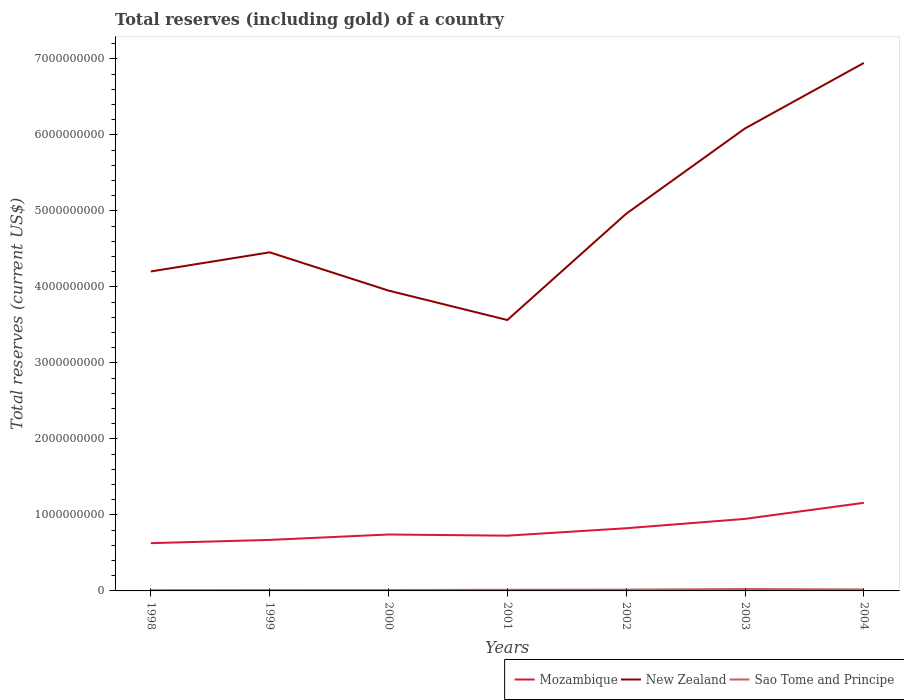How many different coloured lines are there?
Keep it short and to the point. 3. Does the line corresponding to Sao Tome and Principe intersect with the line corresponding to New Zealand?
Your answer should be compact. No. Is the number of lines equal to the number of legend labels?
Provide a succinct answer. Yes. Across all years, what is the maximum total reserves (including gold) in New Zealand?
Provide a succinct answer. 3.56e+09. What is the total total reserves (including gold) in New Zealand in the graph?
Make the answer very short. 6.39e+08. What is the difference between the highest and the second highest total reserves (including gold) in Mozambique?
Ensure brevity in your answer.  5.31e+08. What is the difference between the highest and the lowest total reserves (including gold) in Sao Tome and Principe?
Give a very brief answer. 3. How many lines are there?
Your answer should be very brief. 3. Are the values on the major ticks of Y-axis written in scientific E-notation?
Offer a terse response. No. Does the graph contain grids?
Make the answer very short. No. Where does the legend appear in the graph?
Ensure brevity in your answer.  Bottom right. What is the title of the graph?
Offer a very short reply. Total reserves (including gold) of a country. What is the label or title of the Y-axis?
Offer a very short reply. Total reserves (current US$). What is the Total reserves (current US$) of Mozambique in 1998?
Provide a short and direct response. 6.28e+08. What is the Total reserves (current US$) of New Zealand in 1998?
Make the answer very short. 4.20e+09. What is the Total reserves (current US$) in Sao Tome and Principe in 1998?
Provide a succinct answer. 9.68e+06. What is the Total reserves (current US$) of Mozambique in 1999?
Your answer should be compact. 6.71e+08. What is the Total reserves (current US$) in New Zealand in 1999?
Keep it short and to the point. 4.46e+09. What is the Total reserves (current US$) of Sao Tome and Principe in 1999?
Ensure brevity in your answer.  1.09e+07. What is the Total reserves (current US$) in Mozambique in 2000?
Your answer should be compact. 7.42e+08. What is the Total reserves (current US$) in New Zealand in 2000?
Your answer should be compact. 3.95e+09. What is the Total reserves (current US$) of Sao Tome and Principe in 2000?
Offer a very short reply. 1.16e+07. What is the Total reserves (current US$) of Mozambique in 2001?
Make the answer very short. 7.27e+08. What is the Total reserves (current US$) of New Zealand in 2001?
Provide a succinct answer. 3.56e+09. What is the Total reserves (current US$) in Sao Tome and Principe in 2001?
Your response must be concise. 1.55e+07. What is the Total reserves (current US$) of Mozambique in 2002?
Provide a succinct answer. 8.25e+08. What is the Total reserves (current US$) of New Zealand in 2002?
Your answer should be very brief. 4.96e+09. What is the Total reserves (current US$) in Sao Tome and Principe in 2002?
Make the answer very short. 1.74e+07. What is the Total reserves (current US$) in Mozambique in 2003?
Your response must be concise. 9.48e+08. What is the Total reserves (current US$) in New Zealand in 2003?
Your answer should be compact. 6.09e+09. What is the Total reserves (current US$) in Sao Tome and Principe in 2003?
Your response must be concise. 2.55e+07. What is the Total reserves (current US$) of Mozambique in 2004?
Offer a terse response. 1.16e+09. What is the Total reserves (current US$) of New Zealand in 2004?
Give a very brief answer. 6.95e+09. What is the Total reserves (current US$) in Sao Tome and Principe in 2004?
Provide a succinct answer. 1.95e+07. Across all years, what is the maximum Total reserves (current US$) in Mozambique?
Offer a terse response. 1.16e+09. Across all years, what is the maximum Total reserves (current US$) in New Zealand?
Keep it short and to the point. 6.95e+09. Across all years, what is the maximum Total reserves (current US$) in Sao Tome and Principe?
Make the answer very short. 2.55e+07. Across all years, what is the minimum Total reserves (current US$) in Mozambique?
Offer a terse response. 6.28e+08. Across all years, what is the minimum Total reserves (current US$) of New Zealand?
Provide a succinct answer. 3.56e+09. Across all years, what is the minimum Total reserves (current US$) in Sao Tome and Principe?
Your answer should be very brief. 9.68e+06. What is the total Total reserves (current US$) in Mozambique in the graph?
Your answer should be compact. 5.70e+09. What is the total Total reserves (current US$) of New Zealand in the graph?
Your response must be concise. 3.42e+1. What is the total Total reserves (current US$) in Sao Tome and Principe in the graph?
Your answer should be compact. 1.10e+08. What is the difference between the Total reserves (current US$) of Mozambique in 1998 and that in 1999?
Provide a succinct answer. -4.29e+07. What is the difference between the Total reserves (current US$) in New Zealand in 1998 and that in 1999?
Give a very brief answer. -2.52e+08. What is the difference between the Total reserves (current US$) of Sao Tome and Principe in 1998 and that in 1999?
Give a very brief answer. -1.19e+06. What is the difference between the Total reserves (current US$) of Mozambique in 1998 and that in 2000?
Offer a terse response. -1.14e+08. What is the difference between the Total reserves (current US$) of New Zealand in 1998 and that in 2000?
Make the answer very short. 2.52e+08. What is the difference between the Total reserves (current US$) in Sao Tome and Principe in 1998 and that in 2000?
Offer a terse response. -1.96e+06. What is the difference between the Total reserves (current US$) of Mozambique in 1998 and that in 2001?
Your answer should be very brief. -9.85e+07. What is the difference between the Total reserves (current US$) in New Zealand in 1998 and that in 2001?
Your answer should be compact. 6.39e+08. What is the difference between the Total reserves (current US$) of Sao Tome and Principe in 1998 and that in 2001?
Your answer should be compact. -5.80e+06. What is the difference between the Total reserves (current US$) of Mozambique in 1998 and that in 2002?
Make the answer very short. -1.96e+08. What is the difference between the Total reserves (current US$) in New Zealand in 1998 and that in 2002?
Provide a succinct answer. -7.59e+08. What is the difference between the Total reserves (current US$) of Sao Tome and Principe in 1998 and that in 2002?
Offer a very short reply. -7.67e+06. What is the difference between the Total reserves (current US$) in Mozambique in 1998 and that in 2003?
Offer a terse response. -3.19e+08. What is the difference between the Total reserves (current US$) in New Zealand in 1998 and that in 2003?
Offer a very short reply. -1.88e+09. What is the difference between the Total reserves (current US$) of Sao Tome and Principe in 1998 and that in 2003?
Ensure brevity in your answer.  -1.58e+07. What is the difference between the Total reserves (current US$) of Mozambique in 1998 and that in 2004?
Offer a very short reply. -5.31e+08. What is the difference between the Total reserves (current US$) of New Zealand in 1998 and that in 2004?
Give a very brief answer. -2.74e+09. What is the difference between the Total reserves (current US$) of Sao Tome and Principe in 1998 and that in 2004?
Give a very brief answer. -9.82e+06. What is the difference between the Total reserves (current US$) in Mozambique in 1999 and that in 2000?
Provide a short and direct response. -7.10e+07. What is the difference between the Total reserves (current US$) in New Zealand in 1999 and that in 2000?
Offer a very short reply. 5.03e+08. What is the difference between the Total reserves (current US$) of Sao Tome and Principe in 1999 and that in 2000?
Offer a terse response. -7.62e+05. What is the difference between the Total reserves (current US$) of Mozambique in 1999 and that in 2001?
Keep it short and to the point. -5.56e+07. What is the difference between the Total reserves (current US$) of New Zealand in 1999 and that in 2001?
Your response must be concise. 8.91e+08. What is the difference between the Total reserves (current US$) of Sao Tome and Principe in 1999 and that in 2001?
Make the answer very short. -4.60e+06. What is the difference between the Total reserves (current US$) of Mozambique in 1999 and that in 2002?
Your answer should be very brief. -1.53e+08. What is the difference between the Total reserves (current US$) of New Zealand in 1999 and that in 2002?
Offer a very short reply. -5.07e+08. What is the difference between the Total reserves (current US$) in Sao Tome and Principe in 1999 and that in 2002?
Make the answer very short. -6.48e+06. What is the difference between the Total reserves (current US$) of Mozambique in 1999 and that in 2003?
Offer a terse response. -2.76e+08. What is the difference between the Total reserves (current US$) of New Zealand in 1999 and that in 2003?
Provide a short and direct response. -1.63e+09. What is the difference between the Total reserves (current US$) in Sao Tome and Principe in 1999 and that in 2003?
Provide a succinct answer. -1.46e+07. What is the difference between the Total reserves (current US$) in Mozambique in 1999 and that in 2004?
Provide a short and direct response. -4.88e+08. What is the difference between the Total reserves (current US$) in New Zealand in 1999 and that in 2004?
Provide a succinct answer. -2.49e+09. What is the difference between the Total reserves (current US$) of Sao Tome and Principe in 1999 and that in 2004?
Offer a terse response. -8.63e+06. What is the difference between the Total reserves (current US$) in Mozambique in 2000 and that in 2001?
Give a very brief answer. 1.53e+07. What is the difference between the Total reserves (current US$) of New Zealand in 2000 and that in 2001?
Give a very brief answer. 3.87e+08. What is the difference between the Total reserves (current US$) of Sao Tome and Principe in 2000 and that in 2001?
Your response must be concise. -3.84e+06. What is the difference between the Total reserves (current US$) in Mozambique in 2000 and that in 2002?
Provide a short and direct response. -8.24e+07. What is the difference between the Total reserves (current US$) of New Zealand in 2000 and that in 2002?
Keep it short and to the point. -1.01e+09. What is the difference between the Total reserves (current US$) of Sao Tome and Principe in 2000 and that in 2002?
Provide a succinct answer. -5.71e+06. What is the difference between the Total reserves (current US$) of Mozambique in 2000 and that in 2003?
Offer a very short reply. -2.06e+08. What is the difference between the Total reserves (current US$) of New Zealand in 2000 and that in 2003?
Provide a succinct answer. -2.13e+09. What is the difference between the Total reserves (current US$) in Sao Tome and Principe in 2000 and that in 2003?
Your answer should be very brief. -1.38e+07. What is the difference between the Total reserves (current US$) in Mozambique in 2000 and that in 2004?
Your response must be concise. -4.17e+08. What is the difference between the Total reserves (current US$) in New Zealand in 2000 and that in 2004?
Make the answer very short. -3.00e+09. What is the difference between the Total reserves (current US$) in Sao Tome and Principe in 2000 and that in 2004?
Offer a terse response. -7.86e+06. What is the difference between the Total reserves (current US$) in Mozambique in 2001 and that in 2002?
Your response must be concise. -9.77e+07. What is the difference between the Total reserves (current US$) in New Zealand in 2001 and that in 2002?
Keep it short and to the point. -1.40e+09. What is the difference between the Total reserves (current US$) in Sao Tome and Principe in 2001 and that in 2002?
Make the answer very short. -1.87e+06. What is the difference between the Total reserves (current US$) in Mozambique in 2001 and that in 2003?
Provide a succinct answer. -2.21e+08. What is the difference between the Total reserves (current US$) of New Zealand in 2001 and that in 2003?
Your response must be concise. -2.52e+09. What is the difference between the Total reserves (current US$) in Sao Tome and Principe in 2001 and that in 2003?
Offer a very short reply. -9.99e+06. What is the difference between the Total reserves (current US$) of Mozambique in 2001 and that in 2004?
Keep it short and to the point. -4.32e+08. What is the difference between the Total reserves (current US$) of New Zealand in 2001 and that in 2004?
Give a very brief answer. -3.38e+09. What is the difference between the Total reserves (current US$) in Sao Tome and Principe in 2001 and that in 2004?
Your answer should be very brief. -4.02e+06. What is the difference between the Total reserves (current US$) in Mozambique in 2002 and that in 2003?
Provide a succinct answer. -1.23e+08. What is the difference between the Total reserves (current US$) of New Zealand in 2002 and that in 2003?
Ensure brevity in your answer.  -1.12e+09. What is the difference between the Total reserves (current US$) of Sao Tome and Principe in 2002 and that in 2003?
Provide a succinct answer. -8.12e+06. What is the difference between the Total reserves (current US$) of Mozambique in 2002 and that in 2004?
Provide a succinct answer. -3.35e+08. What is the difference between the Total reserves (current US$) in New Zealand in 2002 and that in 2004?
Give a very brief answer. -1.98e+09. What is the difference between the Total reserves (current US$) of Sao Tome and Principe in 2002 and that in 2004?
Your answer should be very brief. -2.15e+06. What is the difference between the Total reserves (current US$) in Mozambique in 2003 and that in 2004?
Your answer should be very brief. -2.11e+08. What is the difference between the Total reserves (current US$) in New Zealand in 2003 and that in 2004?
Provide a succinct answer. -8.62e+08. What is the difference between the Total reserves (current US$) of Sao Tome and Principe in 2003 and that in 2004?
Give a very brief answer. 5.97e+06. What is the difference between the Total reserves (current US$) in Mozambique in 1998 and the Total reserves (current US$) in New Zealand in 1999?
Give a very brief answer. -3.83e+09. What is the difference between the Total reserves (current US$) in Mozambique in 1998 and the Total reserves (current US$) in Sao Tome and Principe in 1999?
Your answer should be compact. 6.18e+08. What is the difference between the Total reserves (current US$) in New Zealand in 1998 and the Total reserves (current US$) in Sao Tome and Principe in 1999?
Keep it short and to the point. 4.19e+09. What is the difference between the Total reserves (current US$) of Mozambique in 1998 and the Total reserves (current US$) of New Zealand in 2000?
Make the answer very short. -3.32e+09. What is the difference between the Total reserves (current US$) of Mozambique in 1998 and the Total reserves (current US$) of Sao Tome and Principe in 2000?
Offer a terse response. 6.17e+08. What is the difference between the Total reserves (current US$) of New Zealand in 1998 and the Total reserves (current US$) of Sao Tome and Principe in 2000?
Provide a short and direct response. 4.19e+09. What is the difference between the Total reserves (current US$) in Mozambique in 1998 and the Total reserves (current US$) in New Zealand in 2001?
Your answer should be very brief. -2.94e+09. What is the difference between the Total reserves (current US$) of Mozambique in 1998 and the Total reserves (current US$) of Sao Tome and Principe in 2001?
Your response must be concise. 6.13e+08. What is the difference between the Total reserves (current US$) in New Zealand in 1998 and the Total reserves (current US$) in Sao Tome and Principe in 2001?
Keep it short and to the point. 4.19e+09. What is the difference between the Total reserves (current US$) in Mozambique in 1998 and the Total reserves (current US$) in New Zealand in 2002?
Give a very brief answer. -4.33e+09. What is the difference between the Total reserves (current US$) of Mozambique in 1998 and the Total reserves (current US$) of Sao Tome and Principe in 2002?
Your response must be concise. 6.11e+08. What is the difference between the Total reserves (current US$) of New Zealand in 1998 and the Total reserves (current US$) of Sao Tome and Principe in 2002?
Your response must be concise. 4.19e+09. What is the difference between the Total reserves (current US$) of Mozambique in 1998 and the Total reserves (current US$) of New Zealand in 2003?
Your response must be concise. -5.46e+09. What is the difference between the Total reserves (current US$) of Mozambique in 1998 and the Total reserves (current US$) of Sao Tome and Principe in 2003?
Give a very brief answer. 6.03e+08. What is the difference between the Total reserves (current US$) of New Zealand in 1998 and the Total reserves (current US$) of Sao Tome and Principe in 2003?
Give a very brief answer. 4.18e+09. What is the difference between the Total reserves (current US$) in Mozambique in 1998 and the Total reserves (current US$) in New Zealand in 2004?
Keep it short and to the point. -6.32e+09. What is the difference between the Total reserves (current US$) in Mozambique in 1998 and the Total reserves (current US$) in Sao Tome and Principe in 2004?
Offer a terse response. 6.09e+08. What is the difference between the Total reserves (current US$) of New Zealand in 1998 and the Total reserves (current US$) of Sao Tome and Principe in 2004?
Ensure brevity in your answer.  4.18e+09. What is the difference between the Total reserves (current US$) in Mozambique in 1999 and the Total reserves (current US$) in New Zealand in 2000?
Offer a very short reply. -3.28e+09. What is the difference between the Total reserves (current US$) of Mozambique in 1999 and the Total reserves (current US$) of Sao Tome and Principe in 2000?
Make the answer very short. 6.60e+08. What is the difference between the Total reserves (current US$) in New Zealand in 1999 and the Total reserves (current US$) in Sao Tome and Principe in 2000?
Your answer should be very brief. 4.44e+09. What is the difference between the Total reserves (current US$) in Mozambique in 1999 and the Total reserves (current US$) in New Zealand in 2001?
Keep it short and to the point. -2.89e+09. What is the difference between the Total reserves (current US$) of Mozambique in 1999 and the Total reserves (current US$) of Sao Tome and Principe in 2001?
Provide a succinct answer. 6.56e+08. What is the difference between the Total reserves (current US$) in New Zealand in 1999 and the Total reserves (current US$) in Sao Tome and Principe in 2001?
Make the answer very short. 4.44e+09. What is the difference between the Total reserves (current US$) in Mozambique in 1999 and the Total reserves (current US$) in New Zealand in 2002?
Your response must be concise. -4.29e+09. What is the difference between the Total reserves (current US$) of Mozambique in 1999 and the Total reserves (current US$) of Sao Tome and Principe in 2002?
Your response must be concise. 6.54e+08. What is the difference between the Total reserves (current US$) of New Zealand in 1999 and the Total reserves (current US$) of Sao Tome and Principe in 2002?
Your answer should be very brief. 4.44e+09. What is the difference between the Total reserves (current US$) in Mozambique in 1999 and the Total reserves (current US$) in New Zealand in 2003?
Offer a terse response. -5.41e+09. What is the difference between the Total reserves (current US$) of Mozambique in 1999 and the Total reserves (current US$) of Sao Tome and Principe in 2003?
Your answer should be compact. 6.46e+08. What is the difference between the Total reserves (current US$) in New Zealand in 1999 and the Total reserves (current US$) in Sao Tome and Principe in 2003?
Your answer should be compact. 4.43e+09. What is the difference between the Total reserves (current US$) of Mozambique in 1999 and the Total reserves (current US$) of New Zealand in 2004?
Your response must be concise. -6.28e+09. What is the difference between the Total reserves (current US$) in Mozambique in 1999 and the Total reserves (current US$) in Sao Tome and Principe in 2004?
Ensure brevity in your answer.  6.52e+08. What is the difference between the Total reserves (current US$) in New Zealand in 1999 and the Total reserves (current US$) in Sao Tome and Principe in 2004?
Provide a short and direct response. 4.44e+09. What is the difference between the Total reserves (current US$) in Mozambique in 2000 and the Total reserves (current US$) in New Zealand in 2001?
Provide a short and direct response. -2.82e+09. What is the difference between the Total reserves (current US$) in Mozambique in 2000 and the Total reserves (current US$) in Sao Tome and Principe in 2001?
Offer a terse response. 7.27e+08. What is the difference between the Total reserves (current US$) of New Zealand in 2000 and the Total reserves (current US$) of Sao Tome and Principe in 2001?
Offer a very short reply. 3.94e+09. What is the difference between the Total reserves (current US$) in Mozambique in 2000 and the Total reserves (current US$) in New Zealand in 2002?
Your answer should be compact. -4.22e+09. What is the difference between the Total reserves (current US$) in Mozambique in 2000 and the Total reserves (current US$) in Sao Tome and Principe in 2002?
Keep it short and to the point. 7.25e+08. What is the difference between the Total reserves (current US$) in New Zealand in 2000 and the Total reserves (current US$) in Sao Tome and Principe in 2002?
Ensure brevity in your answer.  3.93e+09. What is the difference between the Total reserves (current US$) in Mozambique in 2000 and the Total reserves (current US$) in New Zealand in 2003?
Your answer should be very brief. -5.34e+09. What is the difference between the Total reserves (current US$) in Mozambique in 2000 and the Total reserves (current US$) in Sao Tome and Principe in 2003?
Your answer should be very brief. 7.17e+08. What is the difference between the Total reserves (current US$) of New Zealand in 2000 and the Total reserves (current US$) of Sao Tome and Principe in 2003?
Make the answer very short. 3.93e+09. What is the difference between the Total reserves (current US$) in Mozambique in 2000 and the Total reserves (current US$) in New Zealand in 2004?
Your answer should be compact. -6.21e+09. What is the difference between the Total reserves (current US$) of Mozambique in 2000 and the Total reserves (current US$) of Sao Tome and Principe in 2004?
Ensure brevity in your answer.  7.23e+08. What is the difference between the Total reserves (current US$) of New Zealand in 2000 and the Total reserves (current US$) of Sao Tome and Principe in 2004?
Provide a succinct answer. 3.93e+09. What is the difference between the Total reserves (current US$) of Mozambique in 2001 and the Total reserves (current US$) of New Zealand in 2002?
Give a very brief answer. -4.24e+09. What is the difference between the Total reserves (current US$) of Mozambique in 2001 and the Total reserves (current US$) of Sao Tome and Principe in 2002?
Offer a terse response. 7.10e+08. What is the difference between the Total reserves (current US$) in New Zealand in 2001 and the Total reserves (current US$) in Sao Tome and Principe in 2002?
Ensure brevity in your answer.  3.55e+09. What is the difference between the Total reserves (current US$) in Mozambique in 2001 and the Total reserves (current US$) in New Zealand in 2003?
Your answer should be very brief. -5.36e+09. What is the difference between the Total reserves (current US$) of Mozambique in 2001 and the Total reserves (current US$) of Sao Tome and Principe in 2003?
Provide a succinct answer. 7.02e+08. What is the difference between the Total reserves (current US$) in New Zealand in 2001 and the Total reserves (current US$) in Sao Tome and Principe in 2003?
Give a very brief answer. 3.54e+09. What is the difference between the Total reserves (current US$) of Mozambique in 2001 and the Total reserves (current US$) of New Zealand in 2004?
Provide a short and direct response. -6.22e+09. What is the difference between the Total reserves (current US$) in Mozambique in 2001 and the Total reserves (current US$) in Sao Tome and Principe in 2004?
Provide a succinct answer. 7.07e+08. What is the difference between the Total reserves (current US$) in New Zealand in 2001 and the Total reserves (current US$) in Sao Tome and Principe in 2004?
Give a very brief answer. 3.55e+09. What is the difference between the Total reserves (current US$) in Mozambique in 2002 and the Total reserves (current US$) in New Zealand in 2003?
Your response must be concise. -5.26e+09. What is the difference between the Total reserves (current US$) of Mozambique in 2002 and the Total reserves (current US$) of Sao Tome and Principe in 2003?
Make the answer very short. 7.99e+08. What is the difference between the Total reserves (current US$) in New Zealand in 2002 and the Total reserves (current US$) in Sao Tome and Principe in 2003?
Provide a short and direct response. 4.94e+09. What is the difference between the Total reserves (current US$) of Mozambique in 2002 and the Total reserves (current US$) of New Zealand in 2004?
Your response must be concise. -6.12e+09. What is the difference between the Total reserves (current US$) of Mozambique in 2002 and the Total reserves (current US$) of Sao Tome and Principe in 2004?
Your response must be concise. 8.05e+08. What is the difference between the Total reserves (current US$) of New Zealand in 2002 and the Total reserves (current US$) of Sao Tome and Principe in 2004?
Provide a short and direct response. 4.94e+09. What is the difference between the Total reserves (current US$) of Mozambique in 2003 and the Total reserves (current US$) of New Zealand in 2004?
Your answer should be very brief. -6.00e+09. What is the difference between the Total reserves (current US$) of Mozambique in 2003 and the Total reserves (current US$) of Sao Tome and Principe in 2004?
Provide a short and direct response. 9.28e+08. What is the difference between the Total reserves (current US$) of New Zealand in 2003 and the Total reserves (current US$) of Sao Tome and Principe in 2004?
Provide a short and direct response. 6.07e+09. What is the average Total reserves (current US$) in Mozambique per year?
Keep it short and to the point. 8.14e+08. What is the average Total reserves (current US$) in New Zealand per year?
Keep it short and to the point. 4.88e+09. What is the average Total reserves (current US$) in Sao Tome and Principe per year?
Make the answer very short. 1.57e+07. In the year 1998, what is the difference between the Total reserves (current US$) in Mozambique and Total reserves (current US$) in New Zealand?
Your response must be concise. -3.58e+09. In the year 1998, what is the difference between the Total reserves (current US$) in Mozambique and Total reserves (current US$) in Sao Tome and Principe?
Give a very brief answer. 6.19e+08. In the year 1998, what is the difference between the Total reserves (current US$) in New Zealand and Total reserves (current US$) in Sao Tome and Principe?
Your answer should be compact. 4.19e+09. In the year 1999, what is the difference between the Total reserves (current US$) in Mozambique and Total reserves (current US$) in New Zealand?
Ensure brevity in your answer.  -3.78e+09. In the year 1999, what is the difference between the Total reserves (current US$) in Mozambique and Total reserves (current US$) in Sao Tome and Principe?
Make the answer very short. 6.60e+08. In the year 1999, what is the difference between the Total reserves (current US$) in New Zealand and Total reserves (current US$) in Sao Tome and Principe?
Give a very brief answer. 4.44e+09. In the year 2000, what is the difference between the Total reserves (current US$) in Mozambique and Total reserves (current US$) in New Zealand?
Keep it short and to the point. -3.21e+09. In the year 2000, what is the difference between the Total reserves (current US$) in Mozambique and Total reserves (current US$) in Sao Tome and Principe?
Provide a succinct answer. 7.31e+08. In the year 2000, what is the difference between the Total reserves (current US$) of New Zealand and Total reserves (current US$) of Sao Tome and Principe?
Offer a terse response. 3.94e+09. In the year 2001, what is the difference between the Total reserves (current US$) in Mozambique and Total reserves (current US$) in New Zealand?
Your answer should be compact. -2.84e+09. In the year 2001, what is the difference between the Total reserves (current US$) in Mozambique and Total reserves (current US$) in Sao Tome and Principe?
Provide a succinct answer. 7.11e+08. In the year 2001, what is the difference between the Total reserves (current US$) of New Zealand and Total reserves (current US$) of Sao Tome and Principe?
Ensure brevity in your answer.  3.55e+09. In the year 2002, what is the difference between the Total reserves (current US$) of Mozambique and Total reserves (current US$) of New Zealand?
Make the answer very short. -4.14e+09. In the year 2002, what is the difference between the Total reserves (current US$) in Mozambique and Total reserves (current US$) in Sao Tome and Principe?
Make the answer very short. 8.07e+08. In the year 2002, what is the difference between the Total reserves (current US$) in New Zealand and Total reserves (current US$) in Sao Tome and Principe?
Your response must be concise. 4.95e+09. In the year 2003, what is the difference between the Total reserves (current US$) in Mozambique and Total reserves (current US$) in New Zealand?
Offer a terse response. -5.14e+09. In the year 2003, what is the difference between the Total reserves (current US$) in Mozambique and Total reserves (current US$) in Sao Tome and Principe?
Provide a short and direct response. 9.22e+08. In the year 2003, what is the difference between the Total reserves (current US$) in New Zealand and Total reserves (current US$) in Sao Tome and Principe?
Ensure brevity in your answer.  6.06e+09. In the year 2004, what is the difference between the Total reserves (current US$) in Mozambique and Total reserves (current US$) in New Zealand?
Give a very brief answer. -5.79e+09. In the year 2004, what is the difference between the Total reserves (current US$) of Mozambique and Total reserves (current US$) of Sao Tome and Principe?
Your answer should be compact. 1.14e+09. In the year 2004, what is the difference between the Total reserves (current US$) of New Zealand and Total reserves (current US$) of Sao Tome and Principe?
Provide a succinct answer. 6.93e+09. What is the ratio of the Total reserves (current US$) in Mozambique in 1998 to that in 1999?
Your answer should be compact. 0.94. What is the ratio of the Total reserves (current US$) of New Zealand in 1998 to that in 1999?
Offer a terse response. 0.94. What is the ratio of the Total reserves (current US$) in Sao Tome and Principe in 1998 to that in 1999?
Your answer should be compact. 0.89. What is the ratio of the Total reserves (current US$) of Mozambique in 1998 to that in 2000?
Keep it short and to the point. 0.85. What is the ratio of the Total reserves (current US$) in New Zealand in 1998 to that in 2000?
Your response must be concise. 1.06. What is the ratio of the Total reserves (current US$) of Sao Tome and Principe in 1998 to that in 2000?
Provide a succinct answer. 0.83. What is the ratio of the Total reserves (current US$) in Mozambique in 1998 to that in 2001?
Your answer should be very brief. 0.86. What is the ratio of the Total reserves (current US$) of New Zealand in 1998 to that in 2001?
Offer a very short reply. 1.18. What is the ratio of the Total reserves (current US$) of Sao Tome and Principe in 1998 to that in 2001?
Offer a very short reply. 0.63. What is the ratio of the Total reserves (current US$) of Mozambique in 1998 to that in 2002?
Your answer should be very brief. 0.76. What is the ratio of the Total reserves (current US$) in New Zealand in 1998 to that in 2002?
Offer a terse response. 0.85. What is the ratio of the Total reserves (current US$) in Sao Tome and Principe in 1998 to that in 2002?
Offer a very short reply. 0.56. What is the ratio of the Total reserves (current US$) in Mozambique in 1998 to that in 2003?
Your answer should be compact. 0.66. What is the ratio of the Total reserves (current US$) in New Zealand in 1998 to that in 2003?
Your response must be concise. 0.69. What is the ratio of the Total reserves (current US$) in Sao Tome and Principe in 1998 to that in 2003?
Make the answer very short. 0.38. What is the ratio of the Total reserves (current US$) of Mozambique in 1998 to that in 2004?
Your answer should be compact. 0.54. What is the ratio of the Total reserves (current US$) of New Zealand in 1998 to that in 2004?
Your answer should be compact. 0.61. What is the ratio of the Total reserves (current US$) of Sao Tome and Principe in 1998 to that in 2004?
Keep it short and to the point. 0.5. What is the ratio of the Total reserves (current US$) in Mozambique in 1999 to that in 2000?
Offer a terse response. 0.9. What is the ratio of the Total reserves (current US$) in New Zealand in 1999 to that in 2000?
Provide a short and direct response. 1.13. What is the ratio of the Total reserves (current US$) in Sao Tome and Principe in 1999 to that in 2000?
Offer a terse response. 0.93. What is the ratio of the Total reserves (current US$) of Mozambique in 1999 to that in 2001?
Your answer should be compact. 0.92. What is the ratio of the Total reserves (current US$) in New Zealand in 1999 to that in 2001?
Your answer should be very brief. 1.25. What is the ratio of the Total reserves (current US$) in Sao Tome and Principe in 1999 to that in 2001?
Keep it short and to the point. 0.7. What is the ratio of the Total reserves (current US$) of Mozambique in 1999 to that in 2002?
Ensure brevity in your answer.  0.81. What is the ratio of the Total reserves (current US$) of New Zealand in 1999 to that in 2002?
Make the answer very short. 0.9. What is the ratio of the Total reserves (current US$) in Sao Tome and Principe in 1999 to that in 2002?
Offer a terse response. 0.63. What is the ratio of the Total reserves (current US$) in Mozambique in 1999 to that in 2003?
Ensure brevity in your answer.  0.71. What is the ratio of the Total reserves (current US$) in New Zealand in 1999 to that in 2003?
Your response must be concise. 0.73. What is the ratio of the Total reserves (current US$) of Sao Tome and Principe in 1999 to that in 2003?
Make the answer very short. 0.43. What is the ratio of the Total reserves (current US$) of Mozambique in 1999 to that in 2004?
Your answer should be very brief. 0.58. What is the ratio of the Total reserves (current US$) in New Zealand in 1999 to that in 2004?
Keep it short and to the point. 0.64. What is the ratio of the Total reserves (current US$) of Sao Tome and Principe in 1999 to that in 2004?
Keep it short and to the point. 0.56. What is the ratio of the Total reserves (current US$) of Mozambique in 2000 to that in 2001?
Give a very brief answer. 1.02. What is the ratio of the Total reserves (current US$) in New Zealand in 2000 to that in 2001?
Keep it short and to the point. 1.11. What is the ratio of the Total reserves (current US$) in Sao Tome and Principe in 2000 to that in 2001?
Provide a short and direct response. 0.75. What is the ratio of the Total reserves (current US$) in Mozambique in 2000 to that in 2002?
Provide a succinct answer. 0.9. What is the ratio of the Total reserves (current US$) of New Zealand in 2000 to that in 2002?
Provide a succinct answer. 0.8. What is the ratio of the Total reserves (current US$) in Sao Tome and Principe in 2000 to that in 2002?
Provide a succinct answer. 0.67. What is the ratio of the Total reserves (current US$) in Mozambique in 2000 to that in 2003?
Provide a short and direct response. 0.78. What is the ratio of the Total reserves (current US$) of New Zealand in 2000 to that in 2003?
Your response must be concise. 0.65. What is the ratio of the Total reserves (current US$) in Sao Tome and Principe in 2000 to that in 2003?
Your answer should be very brief. 0.46. What is the ratio of the Total reserves (current US$) of Mozambique in 2000 to that in 2004?
Offer a very short reply. 0.64. What is the ratio of the Total reserves (current US$) in New Zealand in 2000 to that in 2004?
Keep it short and to the point. 0.57. What is the ratio of the Total reserves (current US$) of Sao Tome and Principe in 2000 to that in 2004?
Keep it short and to the point. 0.6. What is the ratio of the Total reserves (current US$) in Mozambique in 2001 to that in 2002?
Ensure brevity in your answer.  0.88. What is the ratio of the Total reserves (current US$) in New Zealand in 2001 to that in 2002?
Ensure brevity in your answer.  0.72. What is the ratio of the Total reserves (current US$) of Sao Tome and Principe in 2001 to that in 2002?
Your response must be concise. 0.89. What is the ratio of the Total reserves (current US$) of Mozambique in 2001 to that in 2003?
Keep it short and to the point. 0.77. What is the ratio of the Total reserves (current US$) in New Zealand in 2001 to that in 2003?
Make the answer very short. 0.59. What is the ratio of the Total reserves (current US$) of Sao Tome and Principe in 2001 to that in 2003?
Your answer should be very brief. 0.61. What is the ratio of the Total reserves (current US$) in Mozambique in 2001 to that in 2004?
Your response must be concise. 0.63. What is the ratio of the Total reserves (current US$) in New Zealand in 2001 to that in 2004?
Keep it short and to the point. 0.51. What is the ratio of the Total reserves (current US$) of Sao Tome and Principe in 2001 to that in 2004?
Keep it short and to the point. 0.79. What is the ratio of the Total reserves (current US$) of Mozambique in 2002 to that in 2003?
Keep it short and to the point. 0.87. What is the ratio of the Total reserves (current US$) of New Zealand in 2002 to that in 2003?
Your response must be concise. 0.82. What is the ratio of the Total reserves (current US$) in Sao Tome and Principe in 2002 to that in 2003?
Provide a short and direct response. 0.68. What is the ratio of the Total reserves (current US$) in Mozambique in 2002 to that in 2004?
Provide a succinct answer. 0.71. What is the ratio of the Total reserves (current US$) of Sao Tome and Principe in 2002 to that in 2004?
Keep it short and to the point. 0.89. What is the ratio of the Total reserves (current US$) in Mozambique in 2003 to that in 2004?
Keep it short and to the point. 0.82. What is the ratio of the Total reserves (current US$) of New Zealand in 2003 to that in 2004?
Your answer should be compact. 0.88. What is the ratio of the Total reserves (current US$) in Sao Tome and Principe in 2003 to that in 2004?
Your response must be concise. 1.31. What is the difference between the highest and the second highest Total reserves (current US$) in Mozambique?
Offer a terse response. 2.11e+08. What is the difference between the highest and the second highest Total reserves (current US$) of New Zealand?
Make the answer very short. 8.62e+08. What is the difference between the highest and the second highest Total reserves (current US$) of Sao Tome and Principe?
Make the answer very short. 5.97e+06. What is the difference between the highest and the lowest Total reserves (current US$) in Mozambique?
Ensure brevity in your answer.  5.31e+08. What is the difference between the highest and the lowest Total reserves (current US$) of New Zealand?
Your answer should be compact. 3.38e+09. What is the difference between the highest and the lowest Total reserves (current US$) of Sao Tome and Principe?
Your response must be concise. 1.58e+07. 